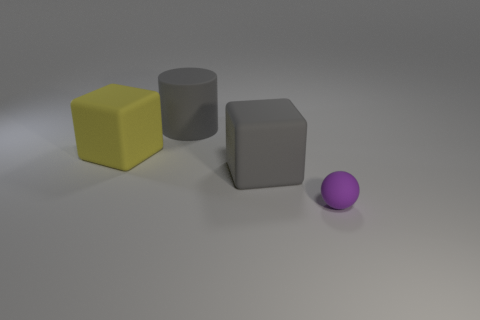Add 4 tiny shiny objects. How many objects exist? 8 Subtract all cylinders. How many objects are left? 3 Add 3 tiny purple matte balls. How many tiny purple matte balls exist? 4 Subtract 0 green blocks. How many objects are left? 4 Subtract all matte cylinders. Subtract all large red rubber balls. How many objects are left? 3 Add 4 purple spheres. How many purple spheres are left? 5 